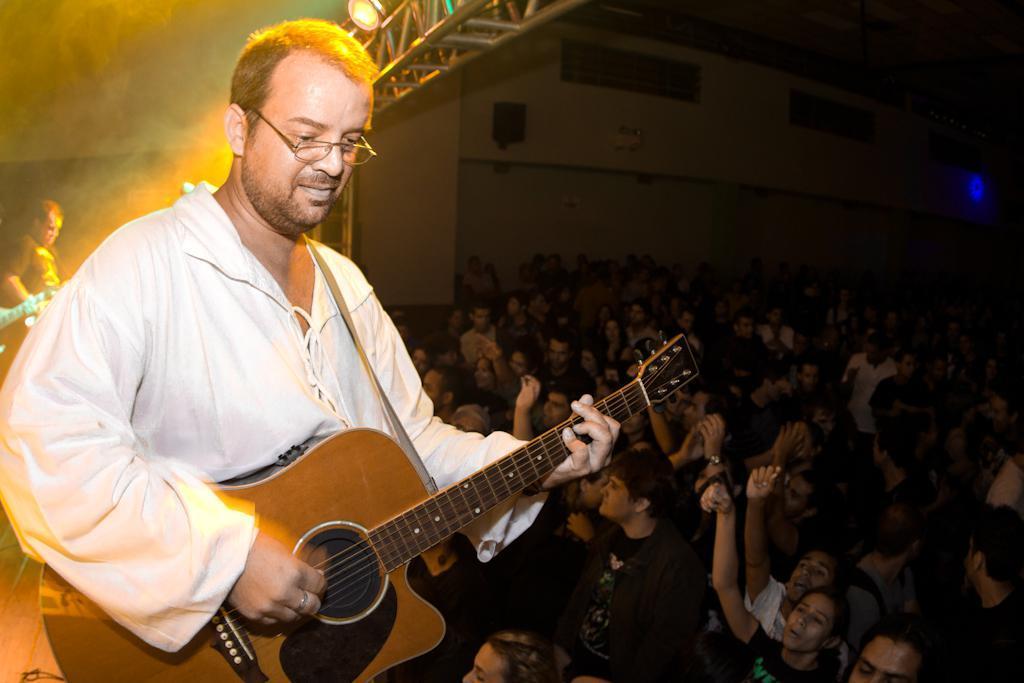In one or two sentences, can you explain what this image depicts? In this image I can see a man is holding a guitar and also he is wearing a specs. In the background I can see few more people. 